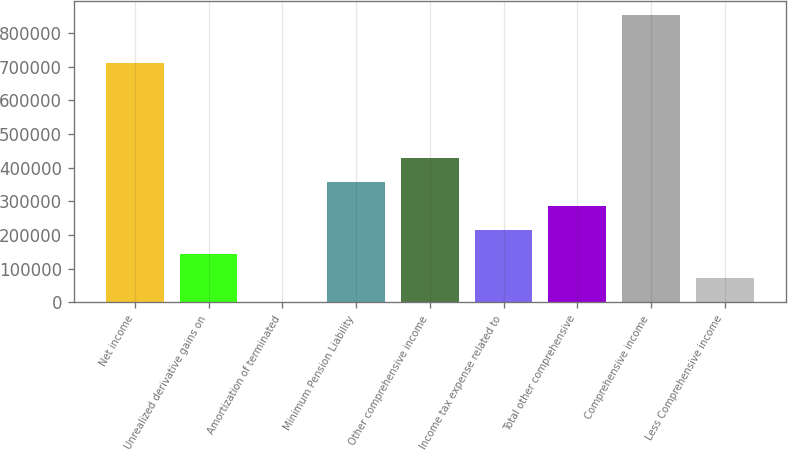Convert chart to OTSL. <chart><loc_0><loc_0><loc_500><loc_500><bar_chart><fcel>Net income<fcel>Unrealized derivative gains on<fcel>Amortization of terminated<fcel>Minimum Pension Liability<fcel>Other comprehensive income<fcel>Income tax expense related to<fcel>Total other comprehensive<fcel>Comprehensive income<fcel>Less Comprehensive income<nl><fcel>709889<fcel>142596<fcel>0.51<fcel>356489<fcel>427786<fcel>213893<fcel>285191<fcel>852484<fcel>71298.2<nl></chart> 